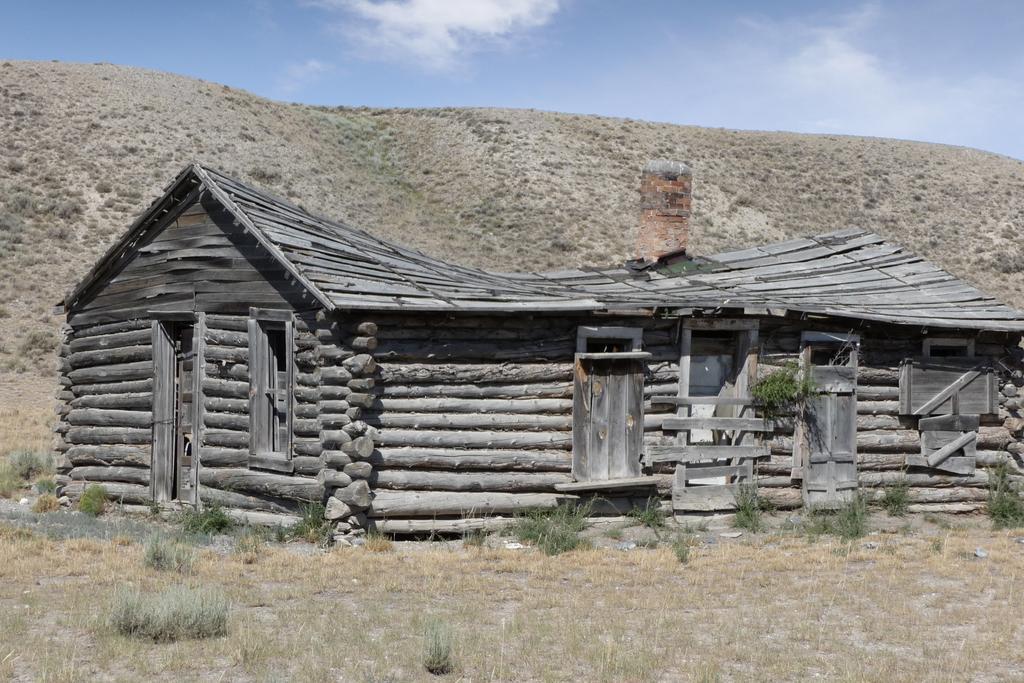Could you give a brief overview of what you see in this image? In this image there is a building windows and doors. And the building is made with woods. On the ground there are plants. In the back there is a hill. In the background there is sky with clouds. 